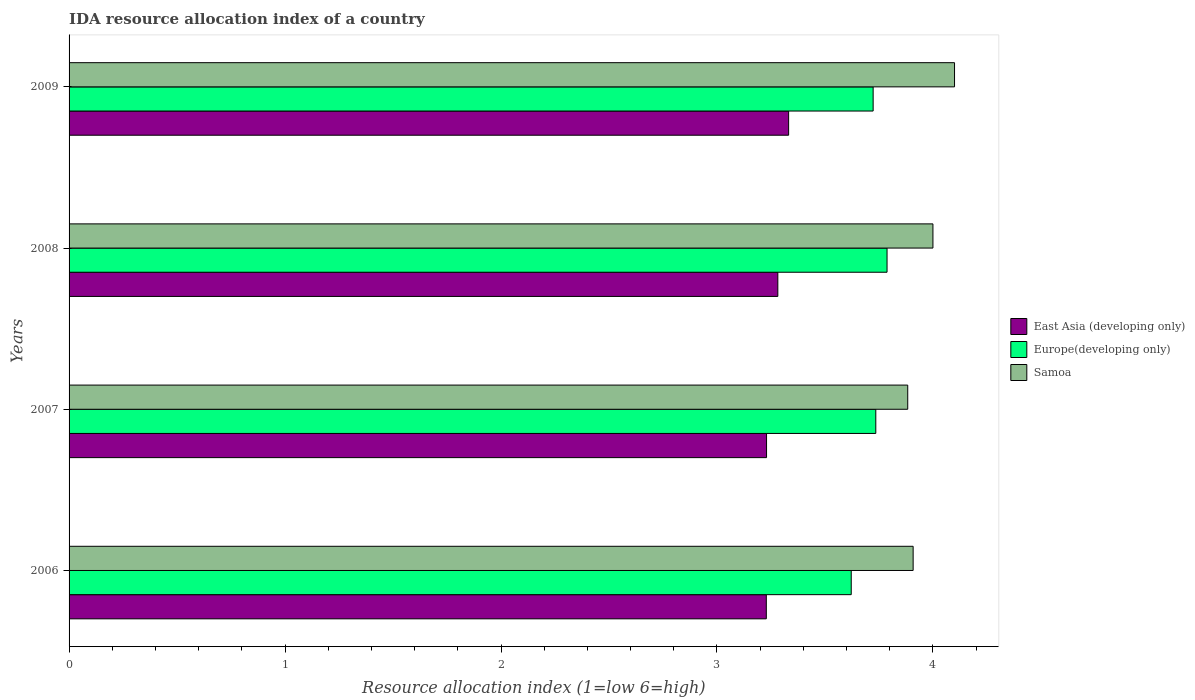How many bars are there on the 3rd tick from the top?
Provide a succinct answer. 3. How many bars are there on the 1st tick from the bottom?
Provide a short and direct response. 3. What is the IDA resource allocation index in Europe(developing only) in 2007?
Offer a very short reply. 3.74. Across all years, what is the maximum IDA resource allocation index in East Asia (developing only)?
Your answer should be very brief. 3.33. Across all years, what is the minimum IDA resource allocation index in Europe(developing only)?
Your answer should be compact. 3.62. What is the total IDA resource allocation index in East Asia (developing only) in the graph?
Give a very brief answer. 13.07. What is the difference between the IDA resource allocation index in East Asia (developing only) in 2007 and that in 2008?
Give a very brief answer. -0.05. What is the difference between the IDA resource allocation index in Europe(developing only) in 2006 and the IDA resource allocation index in Samoa in 2007?
Your answer should be very brief. -0.26. What is the average IDA resource allocation index in Europe(developing only) per year?
Provide a short and direct response. 3.72. In the year 2009, what is the difference between the IDA resource allocation index in Europe(developing only) and IDA resource allocation index in Samoa?
Your response must be concise. -0.38. What is the ratio of the IDA resource allocation index in Europe(developing only) in 2006 to that in 2009?
Provide a short and direct response. 0.97. Is the IDA resource allocation index in Samoa in 2006 less than that in 2009?
Ensure brevity in your answer.  Yes. What is the difference between the highest and the second highest IDA resource allocation index in Samoa?
Offer a terse response. 0.1. What is the difference between the highest and the lowest IDA resource allocation index in Europe(developing only)?
Offer a very short reply. 0.17. In how many years, is the IDA resource allocation index in Europe(developing only) greater than the average IDA resource allocation index in Europe(developing only) taken over all years?
Keep it short and to the point. 3. Is the sum of the IDA resource allocation index in East Asia (developing only) in 2007 and 2009 greater than the maximum IDA resource allocation index in Europe(developing only) across all years?
Make the answer very short. Yes. What does the 1st bar from the top in 2008 represents?
Your response must be concise. Samoa. What does the 1st bar from the bottom in 2008 represents?
Make the answer very short. East Asia (developing only). Are all the bars in the graph horizontal?
Give a very brief answer. Yes. How many years are there in the graph?
Give a very brief answer. 4. What is the difference between two consecutive major ticks on the X-axis?
Make the answer very short. 1. Are the values on the major ticks of X-axis written in scientific E-notation?
Your answer should be compact. No. Where does the legend appear in the graph?
Your answer should be compact. Center right. How many legend labels are there?
Ensure brevity in your answer.  3. What is the title of the graph?
Offer a very short reply. IDA resource allocation index of a country. What is the label or title of the X-axis?
Give a very brief answer. Resource allocation index (1=low 6=high). What is the Resource allocation index (1=low 6=high) of East Asia (developing only) in 2006?
Your answer should be very brief. 3.23. What is the Resource allocation index (1=low 6=high) in Europe(developing only) in 2006?
Offer a terse response. 3.62. What is the Resource allocation index (1=low 6=high) of Samoa in 2006?
Your response must be concise. 3.91. What is the Resource allocation index (1=low 6=high) of East Asia (developing only) in 2007?
Your answer should be very brief. 3.23. What is the Resource allocation index (1=low 6=high) in Europe(developing only) in 2007?
Offer a terse response. 3.74. What is the Resource allocation index (1=low 6=high) in Samoa in 2007?
Your answer should be compact. 3.88. What is the Resource allocation index (1=low 6=high) in East Asia (developing only) in 2008?
Your answer should be very brief. 3.28. What is the Resource allocation index (1=low 6=high) in Europe(developing only) in 2008?
Offer a terse response. 3.79. What is the Resource allocation index (1=low 6=high) of East Asia (developing only) in 2009?
Your answer should be compact. 3.33. What is the Resource allocation index (1=low 6=high) in Europe(developing only) in 2009?
Your answer should be compact. 3.72. What is the Resource allocation index (1=low 6=high) of Samoa in 2009?
Make the answer very short. 4.1. Across all years, what is the maximum Resource allocation index (1=low 6=high) of East Asia (developing only)?
Give a very brief answer. 3.33. Across all years, what is the maximum Resource allocation index (1=low 6=high) of Europe(developing only)?
Make the answer very short. 3.79. Across all years, what is the minimum Resource allocation index (1=low 6=high) in East Asia (developing only)?
Your answer should be compact. 3.23. Across all years, what is the minimum Resource allocation index (1=low 6=high) of Europe(developing only)?
Ensure brevity in your answer.  3.62. Across all years, what is the minimum Resource allocation index (1=low 6=high) of Samoa?
Offer a terse response. 3.88. What is the total Resource allocation index (1=low 6=high) of East Asia (developing only) in the graph?
Offer a terse response. 13.07. What is the total Resource allocation index (1=low 6=high) of Europe(developing only) in the graph?
Provide a short and direct response. 14.87. What is the total Resource allocation index (1=low 6=high) of Samoa in the graph?
Your response must be concise. 15.89. What is the difference between the Resource allocation index (1=low 6=high) in East Asia (developing only) in 2006 and that in 2007?
Keep it short and to the point. -0. What is the difference between the Resource allocation index (1=low 6=high) in Europe(developing only) in 2006 and that in 2007?
Offer a terse response. -0.11. What is the difference between the Resource allocation index (1=low 6=high) of Samoa in 2006 and that in 2007?
Offer a terse response. 0.03. What is the difference between the Resource allocation index (1=low 6=high) in East Asia (developing only) in 2006 and that in 2008?
Give a very brief answer. -0.05. What is the difference between the Resource allocation index (1=low 6=high) in Europe(developing only) in 2006 and that in 2008?
Make the answer very short. -0.17. What is the difference between the Resource allocation index (1=low 6=high) of Samoa in 2006 and that in 2008?
Your answer should be compact. -0.09. What is the difference between the Resource allocation index (1=low 6=high) of East Asia (developing only) in 2006 and that in 2009?
Provide a short and direct response. -0.1. What is the difference between the Resource allocation index (1=low 6=high) of Europe(developing only) in 2006 and that in 2009?
Ensure brevity in your answer.  -0.1. What is the difference between the Resource allocation index (1=low 6=high) of Samoa in 2006 and that in 2009?
Provide a short and direct response. -0.19. What is the difference between the Resource allocation index (1=low 6=high) of East Asia (developing only) in 2007 and that in 2008?
Offer a terse response. -0.05. What is the difference between the Resource allocation index (1=low 6=high) of Europe(developing only) in 2007 and that in 2008?
Your answer should be very brief. -0.05. What is the difference between the Resource allocation index (1=low 6=high) of Samoa in 2007 and that in 2008?
Provide a succinct answer. -0.12. What is the difference between the Resource allocation index (1=low 6=high) in East Asia (developing only) in 2007 and that in 2009?
Make the answer very short. -0.1. What is the difference between the Resource allocation index (1=low 6=high) of Europe(developing only) in 2007 and that in 2009?
Provide a short and direct response. 0.01. What is the difference between the Resource allocation index (1=low 6=high) of Samoa in 2007 and that in 2009?
Offer a very short reply. -0.22. What is the difference between the Resource allocation index (1=low 6=high) of East Asia (developing only) in 2008 and that in 2009?
Offer a terse response. -0.05. What is the difference between the Resource allocation index (1=low 6=high) in Europe(developing only) in 2008 and that in 2009?
Offer a terse response. 0.06. What is the difference between the Resource allocation index (1=low 6=high) in Samoa in 2008 and that in 2009?
Provide a short and direct response. -0.1. What is the difference between the Resource allocation index (1=low 6=high) in East Asia (developing only) in 2006 and the Resource allocation index (1=low 6=high) in Europe(developing only) in 2007?
Offer a very short reply. -0.51. What is the difference between the Resource allocation index (1=low 6=high) of East Asia (developing only) in 2006 and the Resource allocation index (1=low 6=high) of Samoa in 2007?
Your answer should be very brief. -0.65. What is the difference between the Resource allocation index (1=low 6=high) in Europe(developing only) in 2006 and the Resource allocation index (1=low 6=high) in Samoa in 2007?
Your answer should be compact. -0.26. What is the difference between the Resource allocation index (1=low 6=high) of East Asia (developing only) in 2006 and the Resource allocation index (1=low 6=high) of Europe(developing only) in 2008?
Make the answer very short. -0.56. What is the difference between the Resource allocation index (1=low 6=high) in East Asia (developing only) in 2006 and the Resource allocation index (1=low 6=high) in Samoa in 2008?
Provide a succinct answer. -0.77. What is the difference between the Resource allocation index (1=low 6=high) in Europe(developing only) in 2006 and the Resource allocation index (1=low 6=high) in Samoa in 2008?
Offer a terse response. -0.38. What is the difference between the Resource allocation index (1=low 6=high) of East Asia (developing only) in 2006 and the Resource allocation index (1=low 6=high) of Europe(developing only) in 2009?
Offer a very short reply. -0.49. What is the difference between the Resource allocation index (1=low 6=high) of East Asia (developing only) in 2006 and the Resource allocation index (1=low 6=high) of Samoa in 2009?
Make the answer very short. -0.87. What is the difference between the Resource allocation index (1=low 6=high) of Europe(developing only) in 2006 and the Resource allocation index (1=low 6=high) of Samoa in 2009?
Keep it short and to the point. -0.48. What is the difference between the Resource allocation index (1=low 6=high) of East Asia (developing only) in 2007 and the Resource allocation index (1=low 6=high) of Europe(developing only) in 2008?
Make the answer very short. -0.56. What is the difference between the Resource allocation index (1=low 6=high) of East Asia (developing only) in 2007 and the Resource allocation index (1=low 6=high) of Samoa in 2008?
Give a very brief answer. -0.77. What is the difference between the Resource allocation index (1=low 6=high) in Europe(developing only) in 2007 and the Resource allocation index (1=low 6=high) in Samoa in 2008?
Provide a short and direct response. -0.26. What is the difference between the Resource allocation index (1=low 6=high) in East Asia (developing only) in 2007 and the Resource allocation index (1=low 6=high) in Europe(developing only) in 2009?
Offer a very short reply. -0.49. What is the difference between the Resource allocation index (1=low 6=high) in East Asia (developing only) in 2007 and the Resource allocation index (1=low 6=high) in Samoa in 2009?
Your response must be concise. -0.87. What is the difference between the Resource allocation index (1=low 6=high) in Europe(developing only) in 2007 and the Resource allocation index (1=low 6=high) in Samoa in 2009?
Give a very brief answer. -0.36. What is the difference between the Resource allocation index (1=low 6=high) of East Asia (developing only) in 2008 and the Resource allocation index (1=low 6=high) of Europe(developing only) in 2009?
Offer a terse response. -0.44. What is the difference between the Resource allocation index (1=low 6=high) of East Asia (developing only) in 2008 and the Resource allocation index (1=low 6=high) of Samoa in 2009?
Your answer should be very brief. -0.82. What is the difference between the Resource allocation index (1=low 6=high) in Europe(developing only) in 2008 and the Resource allocation index (1=low 6=high) in Samoa in 2009?
Your response must be concise. -0.31. What is the average Resource allocation index (1=low 6=high) of East Asia (developing only) per year?
Your response must be concise. 3.27. What is the average Resource allocation index (1=low 6=high) of Europe(developing only) per year?
Provide a succinct answer. 3.72. What is the average Resource allocation index (1=low 6=high) in Samoa per year?
Provide a short and direct response. 3.97. In the year 2006, what is the difference between the Resource allocation index (1=low 6=high) in East Asia (developing only) and Resource allocation index (1=low 6=high) in Europe(developing only)?
Your answer should be very brief. -0.39. In the year 2006, what is the difference between the Resource allocation index (1=low 6=high) of East Asia (developing only) and Resource allocation index (1=low 6=high) of Samoa?
Provide a short and direct response. -0.68. In the year 2006, what is the difference between the Resource allocation index (1=low 6=high) of Europe(developing only) and Resource allocation index (1=low 6=high) of Samoa?
Offer a very short reply. -0.29. In the year 2007, what is the difference between the Resource allocation index (1=low 6=high) of East Asia (developing only) and Resource allocation index (1=low 6=high) of Europe(developing only)?
Give a very brief answer. -0.51. In the year 2007, what is the difference between the Resource allocation index (1=low 6=high) of East Asia (developing only) and Resource allocation index (1=low 6=high) of Samoa?
Your answer should be very brief. -0.65. In the year 2007, what is the difference between the Resource allocation index (1=low 6=high) of Europe(developing only) and Resource allocation index (1=low 6=high) of Samoa?
Your answer should be very brief. -0.15. In the year 2008, what is the difference between the Resource allocation index (1=low 6=high) of East Asia (developing only) and Resource allocation index (1=low 6=high) of Europe(developing only)?
Give a very brief answer. -0.51. In the year 2008, what is the difference between the Resource allocation index (1=low 6=high) of East Asia (developing only) and Resource allocation index (1=low 6=high) of Samoa?
Offer a terse response. -0.72. In the year 2008, what is the difference between the Resource allocation index (1=low 6=high) in Europe(developing only) and Resource allocation index (1=low 6=high) in Samoa?
Offer a terse response. -0.21. In the year 2009, what is the difference between the Resource allocation index (1=low 6=high) of East Asia (developing only) and Resource allocation index (1=low 6=high) of Europe(developing only)?
Make the answer very short. -0.39. In the year 2009, what is the difference between the Resource allocation index (1=low 6=high) in East Asia (developing only) and Resource allocation index (1=low 6=high) in Samoa?
Offer a very short reply. -0.77. In the year 2009, what is the difference between the Resource allocation index (1=low 6=high) in Europe(developing only) and Resource allocation index (1=low 6=high) in Samoa?
Give a very brief answer. -0.38. What is the ratio of the Resource allocation index (1=low 6=high) in Europe(developing only) in 2006 to that in 2007?
Your answer should be very brief. 0.97. What is the ratio of the Resource allocation index (1=low 6=high) in Samoa in 2006 to that in 2007?
Offer a very short reply. 1.01. What is the ratio of the Resource allocation index (1=low 6=high) of East Asia (developing only) in 2006 to that in 2008?
Give a very brief answer. 0.98. What is the ratio of the Resource allocation index (1=low 6=high) in Europe(developing only) in 2006 to that in 2008?
Offer a terse response. 0.96. What is the ratio of the Resource allocation index (1=low 6=high) of Samoa in 2006 to that in 2008?
Offer a very short reply. 0.98. What is the ratio of the Resource allocation index (1=low 6=high) of East Asia (developing only) in 2006 to that in 2009?
Offer a very short reply. 0.97. What is the ratio of the Resource allocation index (1=low 6=high) in Europe(developing only) in 2006 to that in 2009?
Ensure brevity in your answer.  0.97. What is the ratio of the Resource allocation index (1=low 6=high) in Samoa in 2006 to that in 2009?
Your response must be concise. 0.95. What is the ratio of the Resource allocation index (1=low 6=high) in East Asia (developing only) in 2007 to that in 2008?
Your response must be concise. 0.98. What is the ratio of the Resource allocation index (1=low 6=high) in Europe(developing only) in 2007 to that in 2008?
Your response must be concise. 0.99. What is the ratio of the Resource allocation index (1=low 6=high) in Samoa in 2007 to that in 2008?
Make the answer very short. 0.97. What is the ratio of the Resource allocation index (1=low 6=high) in East Asia (developing only) in 2007 to that in 2009?
Make the answer very short. 0.97. What is the ratio of the Resource allocation index (1=low 6=high) in Europe(developing only) in 2007 to that in 2009?
Give a very brief answer. 1. What is the ratio of the Resource allocation index (1=low 6=high) of Samoa in 2007 to that in 2009?
Ensure brevity in your answer.  0.95. What is the ratio of the Resource allocation index (1=low 6=high) of Europe(developing only) in 2008 to that in 2009?
Offer a very short reply. 1.02. What is the ratio of the Resource allocation index (1=low 6=high) in Samoa in 2008 to that in 2009?
Your response must be concise. 0.98. What is the difference between the highest and the second highest Resource allocation index (1=low 6=high) in Europe(developing only)?
Give a very brief answer. 0.05. What is the difference between the highest and the lowest Resource allocation index (1=low 6=high) in East Asia (developing only)?
Offer a terse response. 0.1. What is the difference between the highest and the lowest Resource allocation index (1=low 6=high) of Europe(developing only)?
Keep it short and to the point. 0.17. What is the difference between the highest and the lowest Resource allocation index (1=low 6=high) in Samoa?
Ensure brevity in your answer.  0.22. 